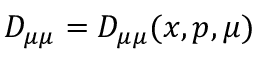<formula> <loc_0><loc_0><loc_500><loc_500>D _ { \mu \mu } = D _ { \mu \mu } ( x , p , \mu )</formula> 